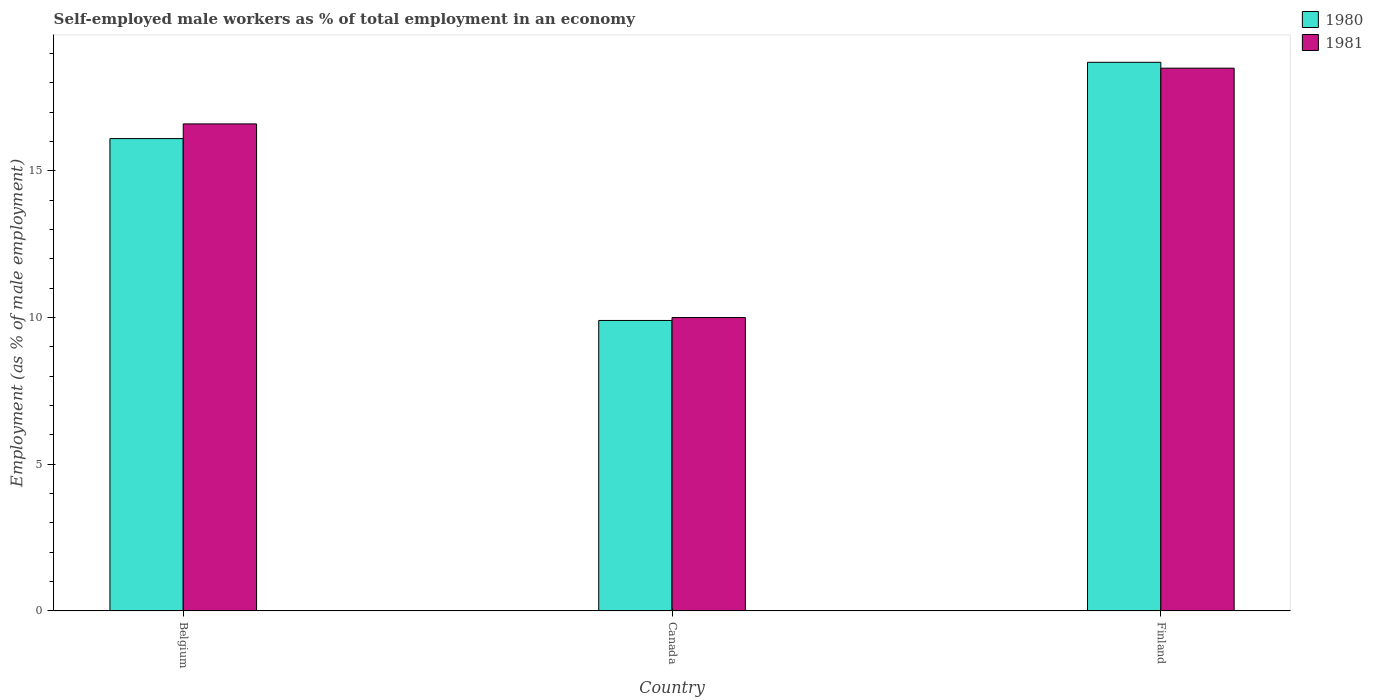How many bars are there on the 3rd tick from the left?
Offer a terse response. 2. What is the percentage of self-employed male workers in 1980 in Canada?
Offer a terse response. 9.9. What is the total percentage of self-employed male workers in 1980 in the graph?
Your response must be concise. 44.7. What is the difference between the percentage of self-employed male workers in 1981 in Belgium and that in Finland?
Your answer should be very brief. -1.9. What is the difference between the percentage of self-employed male workers in 1981 in Finland and the percentage of self-employed male workers in 1980 in Canada?
Make the answer very short. 8.6. What is the average percentage of self-employed male workers in 1981 per country?
Offer a terse response. 15.03. What is the difference between the percentage of self-employed male workers of/in 1981 and percentage of self-employed male workers of/in 1980 in Finland?
Offer a very short reply. -0.2. What is the ratio of the percentage of self-employed male workers in 1980 in Canada to that in Finland?
Your answer should be compact. 0.53. Is the percentage of self-employed male workers in 1981 in Belgium less than that in Canada?
Ensure brevity in your answer.  No. Is the difference between the percentage of self-employed male workers in 1981 in Canada and Finland greater than the difference between the percentage of self-employed male workers in 1980 in Canada and Finland?
Give a very brief answer. Yes. What is the difference between the highest and the second highest percentage of self-employed male workers in 1980?
Your response must be concise. 6.2. What is the difference between two consecutive major ticks on the Y-axis?
Keep it short and to the point. 5. How are the legend labels stacked?
Make the answer very short. Vertical. What is the title of the graph?
Provide a short and direct response. Self-employed male workers as % of total employment in an economy. What is the label or title of the X-axis?
Your answer should be compact. Country. What is the label or title of the Y-axis?
Ensure brevity in your answer.  Employment (as % of male employment). What is the Employment (as % of male employment) of 1980 in Belgium?
Your answer should be compact. 16.1. What is the Employment (as % of male employment) of 1981 in Belgium?
Your answer should be very brief. 16.6. What is the Employment (as % of male employment) in 1980 in Canada?
Give a very brief answer. 9.9. What is the Employment (as % of male employment) of 1981 in Canada?
Make the answer very short. 10. What is the Employment (as % of male employment) of 1980 in Finland?
Give a very brief answer. 18.7. What is the Employment (as % of male employment) of 1981 in Finland?
Your response must be concise. 18.5. Across all countries, what is the maximum Employment (as % of male employment) in 1980?
Your answer should be compact. 18.7. Across all countries, what is the maximum Employment (as % of male employment) of 1981?
Offer a very short reply. 18.5. Across all countries, what is the minimum Employment (as % of male employment) in 1980?
Offer a terse response. 9.9. Across all countries, what is the minimum Employment (as % of male employment) in 1981?
Keep it short and to the point. 10. What is the total Employment (as % of male employment) in 1980 in the graph?
Offer a terse response. 44.7. What is the total Employment (as % of male employment) in 1981 in the graph?
Your answer should be very brief. 45.1. What is the difference between the Employment (as % of male employment) of 1980 in Belgium and that in Canada?
Give a very brief answer. 6.2. What is the difference between the Employment (as % of male employment) in 1980 in Belgium and that in Finland?
Keep it short and to the point. -2.6. What is the difference between the Employment (as % of male employment) of 1981 in Canada and that in Finland?
Keep it short and to the point. -8.5. What is the difference between the Employment (as % of male employment) in 1980 in Belgium and the Employment (as % of male employment) in 1981 in Canada?
Give a very brief answer. 6.1. What is the average Employment (as % of male employment) in 1981 per country?
Your answer should be very brief. 15.03. What is the difference between the Employment (as % of male employment) of 1980 and Employment (as % of male employment) of 1981 in Belgium?
Offer a very short reply. -0.5. What is the ratio of the Employment (as % of male employment) in 1980 in Belgium to that in Canada?
Keep it short and to the point. 1.63. What is the ratio of the Employment (as % of male employment) of 1981 in Belgium to that in Canada?
Ensure brevity in your answer.  1.66. What is the ratio of the Employment (as % of male employment) in 1980 in Belgium to that in Finland?
Make the answer very short. 0.86. What is the ratio of the Employment (as % of male employment) in 1981 in Belgium to that in Finland?
Give a very brief answer. 0.9. What is the ratio of the Employment (as % of male employment) in 1980 in Canada to that in Finland?
Your response must be concise. 0.53. What is the ratio of the Employment (as % of male employment) of 1981 in Canada to that in Finland?
Provide a short and direct response. 0.54. What is the difference between the highest and the second highest Employment (as % of male employment) of 1980?
Make the answer very short. 2.6. What is the difference between the highest and the lowest Employment (as % of male employment) of 1981?
Provide a succinct answer. 8.5. 